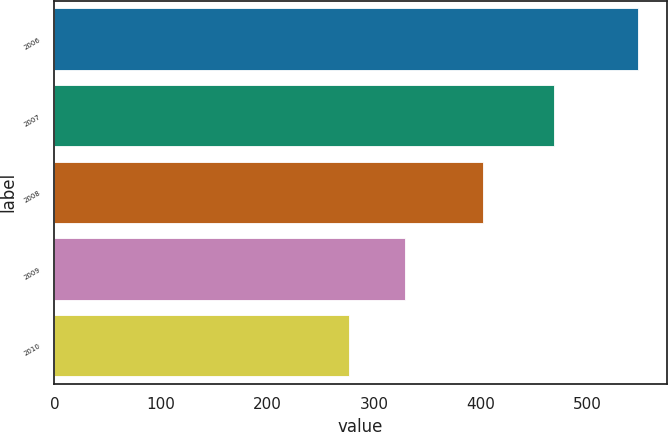Convert chart to OTSL. <chart><loc_0><loc_0><loc_500><loc_500><bar_chart><fcel>2006<fcel>2007<fcel>2008<fcel>2009<fcel>2010<nl><fcel>547<fcel>469<fcel>402<fcel>329<fcel>276<nl></chart> 